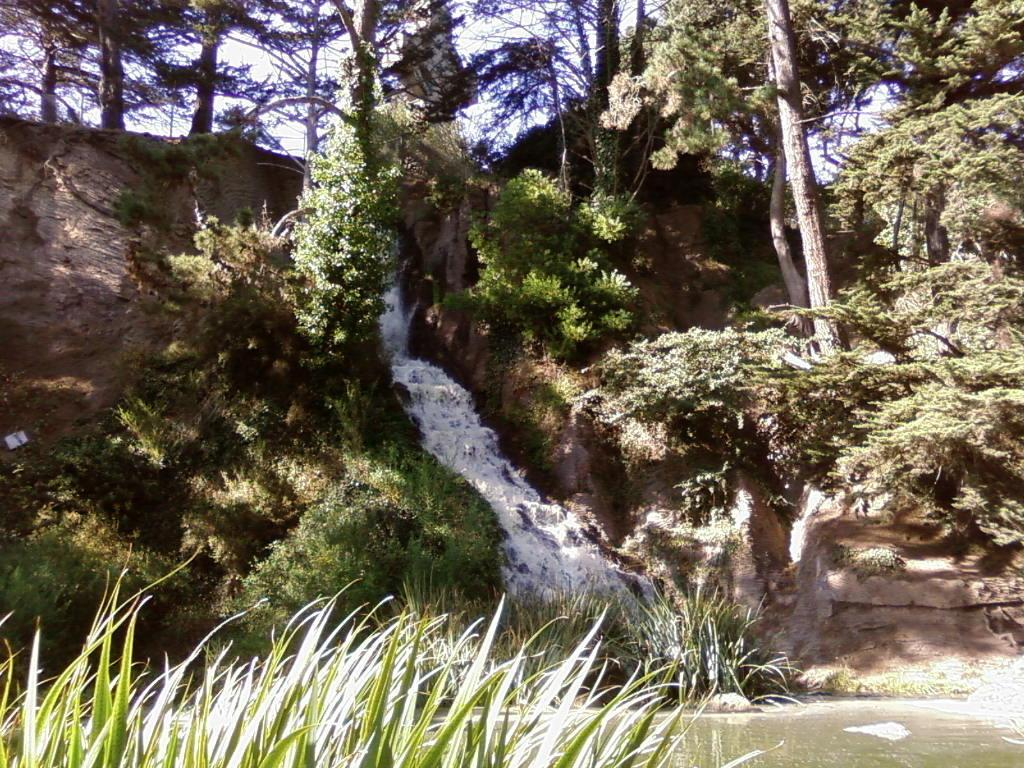What natural feature is the main subject of the image? There is a waterfall in the image. What type of vegetation can be seen in the image? There are plants and trees in the image. What is the terrain like in the image? There is a hill in the image. What is visible behind the trees in the image? The sky is visible behind the trees in the image. Reasoning: Let'ing: Let's think step by step in order to produce the conversation. We start by identifying the main subject of the image, which is the waterfall. Then, we describe the vegetation and terrain present in the image, including plants, trees, and a hill. Finally, we mention the sky visible behind the trees. Each question is designed to elicit a specific detail about the image that is known from the provided facts. Absurd Question/Answer: Where is the fireman located in the image? There is no fireman present in the image. What type of light bulb is used in the image? There is no light bulb present in the image. What type of recess can be seen in the image? There is no recess present in the image. 